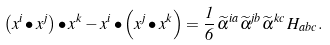Convert formula to latex. <formula><loc_0><loc_0><loc_500><loc_500>\left ( x ^ { i } \bullet x ^ { j } \right ) \bullet x ^ { k } - x ^ { i } \bullet \left ( x ^ { j } \bullet x ^ { k } \right ) = \frac { 1 } { 6 } \, \widetilde { \alpha } ^ { i a } \widetilde { \alpha } ^ { j b } \widetilde { \alpha } ^ { k c } \, H _ { a b c } .</formula> 